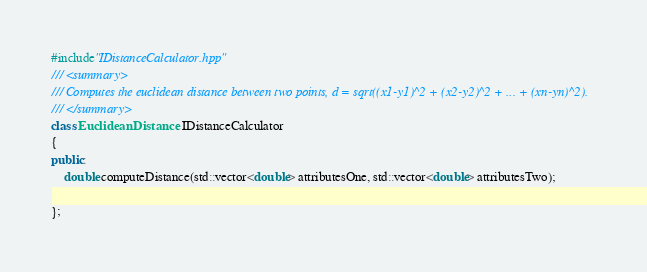<code> <loc_0><loc_0><loc_500><loc_500><_C++_>#include"IDistanceCalculator.hpp"
/// <summary>
/// Computes the euclidean distance between two points, d = sqrt((x1-y1)^2 + (x2-y2)^2 + ... + (xn-yn)^2).
/// </summary>
class EuclideanDistance : IDistanceCalculator
{
public:
	double computeDistance(std::vector<double> attributesOne, std::vector<double> attributesTwo);

};

</code> 